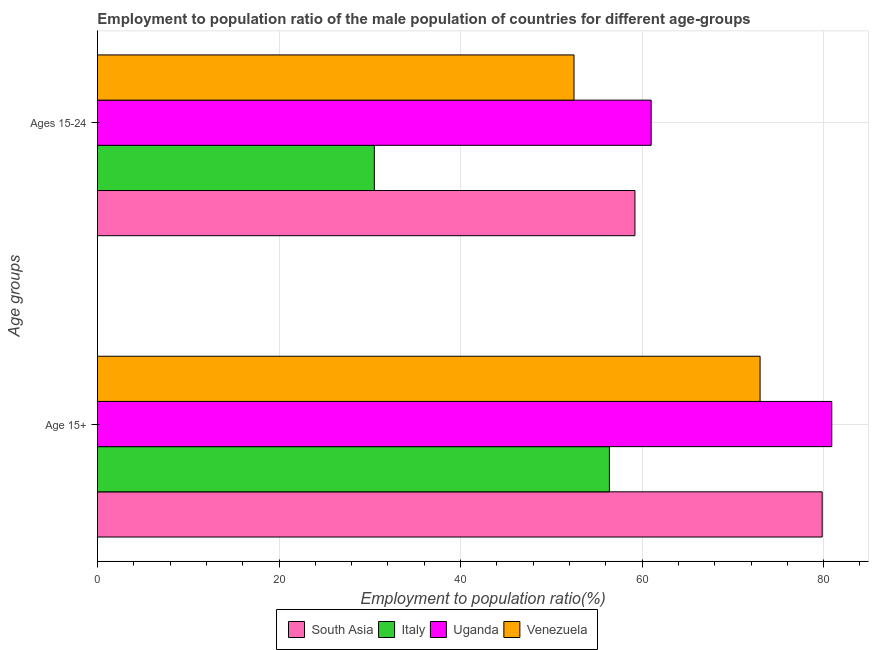How many different coloured bars are there?
Give a very brief answer. 4. Are the number of bars on each tick of the Y-axis equal?
Your answer should be very brief. Yes. How many bars are there on the 2nd tick from the top?
Provide a short and direct response. 4. What is the label of the 2nd group of bars from the top?
Give a very brief answer. Age 15+. What is the employment to population ratio(age 15-24) in South Asia?
Keep it short and to the point. 59.21. Across all countries, what is the maximum employment to population ratio(age 15+)?
Provide a short and direct response. 80.9. Across all countries, what is the minimum employment to population ratio(age 15+)?
Make the answer very short. 56.4. In which country was the employment to population ratio(age 15-24) maximum?
Your response must be concise. Uganda. What is the total employment to population ratio(age 15+) in the graph?
Your response must be concise. 290.14. What is the difference between the employment to population ratio(age 15+) in Venezuela and that in Uganda?
Ensure brevity in your answer.  -7.9. What is the difference between the employment to population ratio(age 15-24) in Italy and the employment to population ratio(age 15+) in Venezuela?
Provide a succinct answer. -42.5. What is the average employment to population ratio(age 15+) per country?
Provide a succinct answer. 72.54. What is the difference between the employment to population ratio(age 15-24) and employment to population ratio(age 15+) in Italy?
Your answer should be very brief. -25.9. In how many countries, is the employment to population ratio(age 15-24) greater than 36 %?
Offer a very short reply. 3. What is the ratio of the employment to population ratio(age 15-24) in Italy to that in Venezuela?
Your answer should be compact. 0.58. Is the employment to population ratio(age 15+) in Uganda less than that in Venezuela?
Your answer should be very brief. No. What does the 1st bar from the top in Ages 15-24 represents?
Provide a short and direct response. Venezuela. What does the 2nd bar from the bottom in Age 15+ represents?
Give a very brief answer. Italy. How many bars are there?
Keep it short and to the point. 8. How many countries are there in the graph?
Make the answer very short. 4. What is the difference between two consecutive major ticks on the X-axis?
Your answer should be compact. 20. Are the values on the major ticks of X-axis written in scientific E-notation?
Your response must be concise. No. Where does the legend appear in the graph?
Offer a terse response. Bottom center. How many legend labels are there?
Ensure brevity in your answer.  4. What is the title of the graph?
Your response must be concise. Employment to population ratio of the male population of countries for different age-groups. Does "Morocco" appear as one of the legend labels in the graph?
Offer a very short reply. No. What is the label or title of the Y-axis?
Offer a very short reply. Age groups. What is the Employment to population ratio(%) of South Asia in Age 15+?
Ensure brevity in your answer.  79.84. What is the Employment to population ratio(%) of Italy in Age 15+?
Give a very brief answer. 56.4. What is the Employment to population ratio(%) in Uganda in Age 15+?
Ensure brevity in your answer.  80.9. What is the Employment to population ratio(%) of South Asia in Ages 15-24?
Ensure brevity in your answer.  59.21. What is the Employment to population ratio(%) of Italy in Ages 15-24?
Ensure brevity in your answer.  30.5. What is the Employment to population ratio(%) in Uganda in Ages 15-24?
Your answer should be very brief. 61. What is the Employment to population ratio(%) of Venezuela in Ages 15-24?
Give a very brief answer. 52.5. Across all Age groups, what is the maximum Employment to population ratio(%) of South Asia?
Your response must be concise. 79.84. Across all Age groups, what is the maximum Employment to population ratio(%) in Italy?
Offer a terse response. 56.4. Across all Age groups, what is the maximum Employment to population ratio(%) of Uganda?
Provide a succinct answer. 80.9. Across all Age groups, what is the minimum Employment to population ratio(%) in South Asia?
Your answer should be compact. 59.21. Across all Age groups, what is the minimum Employment to population ratio(%) in Italy?
Keep it short and to the point. 30.5. Across all Age groups, what is the minimum Employment to population ratio(%) of Uganda?
Your answer should be compact. 61. Across all Age groups, what is the minimum Employment to population ratio(%) in Venezuela?
Provide a succinct answer. 52.5. What is the total Employment to population ratio(%) in South Asia in the graph?
Ensure brevity in your answer.  139.06. What is the total Employment to population ratio(%) in Italy in the graph?
Your answer should be very brief. 86.9. What is the total Employment to population ratio(%) in Uganda in the graph?
Your answer should be very brief. 141.9. What is the total Employment to population ratio(%) of Venezuela in the graph?
Your answer should be very brief. 125.5. What is the difference between the Employment to population ratio(%) of South Asia in Age 15+ and that in Ages 15-24?
Offer a terse response. 20.63. What is the difference between the Employment to population ratio(%) of Italy in Age 15+ and that in Ages 15-24?
Offer a terse response. 25.9. What is the difference between the Employment to population ratio(%) in Uganda in Age 15+ and that in Ages 15-24?
Offer a terse response. 19.9. What is the difference between the Employment to population ratio(%) of Venezuela in Age 15+ and that in Ages 15-24?
Offer a very short reply. 20.5. What is the difference between the Employment to population ratio(%) in South Asia in Age 15+ and the Employment to population ratio(%) in Italy in Ages 15-24?
Offer a very short reply. 49.34. What is the difference between the Employment to population ratio(%) in South Asia in Age 15+ and the Employment to population ratio(%) in Uganda in Ages 15-24?
Ensure brevity in your answer.  18.84. What is the difference between the Employment to population ratio(%) in South Asia in Age 15+ and the Employment to population ratio(%) in Venezuela in Ages 15-24?
Offer a very short reply. 27.34. What is the difference between the Employment to population ratio(%) in Italy in Age 15+ and the Employment to population ratio(%) in Venezuela in Ages 15-24?
Make the answer very short. 3.9. What is the difference between the Employment to population ratio(%) of Uganda in Age 15+ and the Employment to population ratio(%) of Venezuela in Ages 15-24?
Your answer should be very brief. 28.4. What is the average Employment to population ratio(%) in South Asia per Age groups?
Offer a very short reply. 69.53. What is the average Employment to population ratio(%) of Italy per Age groups?
Your answer should be very brief. 43.45. What is the average Employment to population ratio(%) in Uganda per Age groups?
Keep it short and to the point. 70.95. What is the average Employment to population ratio(%) in Venezuela per Age groups?
Ensure brevity in your answer.  62.75. What is the difference between the Employment to population ratio(%) of South Asia and Employment to population ratio(%) of Italy in Age 15+?
Your response must be concise. 23.44. What is the difference between the Employment to population ratio(%) in South Asia and Employment to population ratio(%) in Uganda in Age 15+?
Keep it short and to the point. -1.06. What is the difference between the Employment to population ratio(%) of South Asia and Employment to population ratio(%) of Venezuela in Age 15+?
Make the answer very short. 6.84. What is the difference between the Employment to population ratio(%) in Italy and Employment to population ratio(%) in Uganda in Age 15+?
Offer a very short reply. -24.5. What is the difference between the Employment to population ratio(%) in Italy and Employment to population ratio(%) in Venezuela in Age 15+?
Keep it short and to the point. -16.6. What is the difference between the Employment to population ratio(%) of Uganda and Employment to population ratio(%) of Venezuela in Age 15+?
Ensure brevity in your answer.  7.9. What is the difference between the Employment to population ratio(%) in South Asia and Employment to population ratio(%) in Italy in Ages 15-24?
Ensure brevity in your answer.  28.71. What is the difference between the Employment to population ratio(%) of South Asia and Employment to population ratio(%) of Uganda in Ages 15-24?
Offer a terse response. -1.79. What is the difference between the Employment to population ratio(%) of South Asia and Employment to population ratio(%) of Venezuela in Ages 15-24?
Keep it short and to the point. 6.71. What is the difference between the Employment to population ratio(%) in Italy and Employment to population ratio(%) in Uganda in Ages 15-24?
Your answer should be very brief. -30.5. What is the difference between the Employment to population ratio(%) of Uganda and Employment to population ratio(%) of Venezuela in Ages 15-24?
Offer a terse response. 8.5. What is the ratio of the Employment to population ratio(%) of South Asia in Age 15+ to that in Ages 15-24?
Give a very brief answer. 1.35. What is the ratio of the Employment to population ratio(%) in Italy in Age 15+ to that in Ages 15-24?
Offer a very short reply. 1.85. What is the ratio of the Employment to population ratio(%) in Uganda in Age 15+ to that in Ages 15-24?
Ensure brevity in your answer.  1.33. What is the ratio of the Employment to population ratio(%) of Venezuela in Age 15+ to that in Ages 15-24?
Make the answer very short. 1.39. What is the difference between the highest and the second highest Employment to population ratio(%) in South Asia?
Make the answer very short. 20.63. What is the difference between the highest and the second highest Employment to population ratio(%) of Italy?
Ensure brevity in your answer.  25.9. What is the difference between the highest and the lowest Employment to population ratio(%) of South Asia?
Your response must be concise. 20.63. What is the difference between the highest and the lowest Employment to population ratio(%) of Italy?
Offer a very short reply. 25.9. What is the difference between the highest and the lowest Employment to population ratio(%) of Venezuela?
Keep it short and to the point. 20.5. 